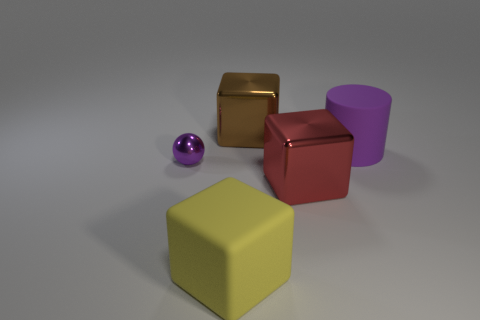How many other objects are the same color as the big cylinder?
Offer a very short reply. 1. How many purple matte objects are left of the matte thing that is on the left side of the large purple rubber object?
Offer a terse response. 0. Are there any large brown shiny cubes on the right side of the big yellow matte cube?
Provide a succinct answer. Yes. There is a shiny thing in front of the purple thing left of the yellow thing; what is its shape?
Offer a very short reply. Cube. Are there fewer small metallic spheres that are behind the large purple rubber thing than large purple matte cylinders behind the big brown block?
Your response must be concise. No. There is another matte object that is the same shape as the big brown thing; what color is it?
Give a very brief answer. Yellow. How many objects are left of the brown block and behind the big yellow rubber cube?
Offer a terse response. 1. Are there more big rubber cylinders that are behind the big purple rubber thing than big brown metal things that are in front of the small sphere?
Offer a terse response. No. The yellow rubber block has what size?
Give a very brief answer. Large. Is there a green thing of the same shape as the large yellow matte thing?
Make the answer very short. No. 